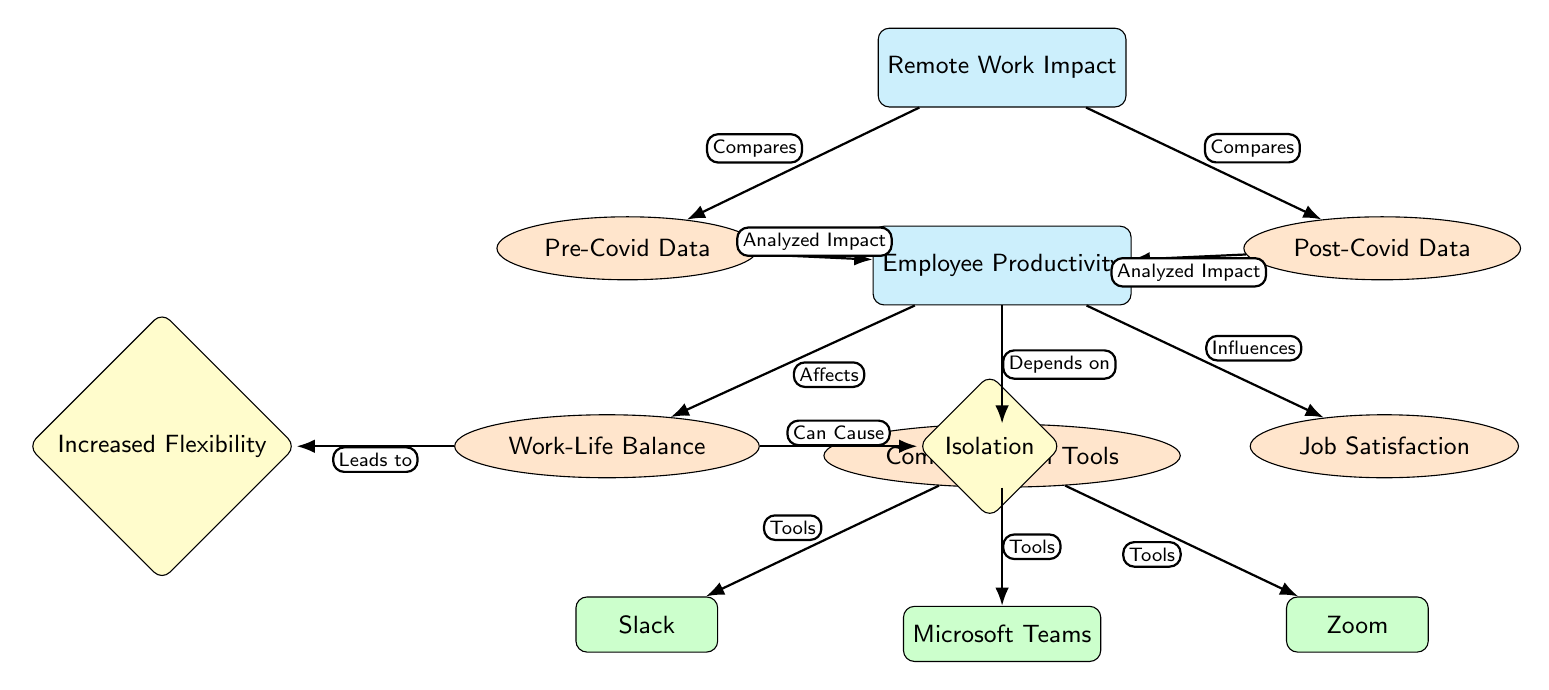What is the main topic of the diagram? The central node labeled "Remote Work Impact" indicates that the diagram focuses on the effects of remote work on various aspects of employee productivity.
Answer: Remote Work Impact How many nodes are present in the diagram? Counting all the nodes, including main, sub, tool, and effect types, the diagram consists of 12 nodes.
Answer: 12 What node influences Job Satisfaction? The diagram shows that "Employee Productivity" influences "Job Satisfaction," indicating a direct relationship between these two nodes.
Answer: Employee Productivity Which communication tool is listed first? The first node under the "Communication Tools" section is "Slack," which is positioned above the other tools in the diagram.
Answer: Slack What effect can result from Work-Life Balance? The diagram indicates that "Work-Life Balance" can lead to "Increased Flexibility," showing a positive correlation between these two concepts.
Answer: Increased Flexibility What does the arrow labeled "Analyzed Impact" connect? The arrows labeled "Analyzed Impact" connect the "Pre-Covid Data" and "Post-Covid Data" nodes to "Employee Productivity," indicating that both data sets provide insights into productivity.
Answer: Pre-Covid Data and Post-Covid Data What relationship does the "Isolation" effect have with Work-Life Balance? In the diagram, "Work-Life Balance" can cause "Isolation," suggesting that while trying to balance work and personal life, employees may feel isolated.
Answer: Can Cause How many tools are identified under Communication Tools? The diagram identifies three tools under the "Communication Tools" section: Slack, Microsoft Teams, and Zoom.
Answer: 3 Which data category compares the Pre and Post-Covid data? The arrows labeled "Compares" indicate that both the "Pre-Covid Data" and "Post-Covid Data" are compared in the context of the diagram.
Answer: Remote Work Impact 